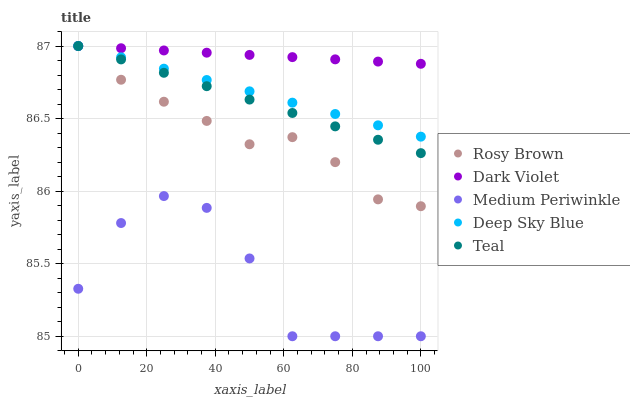Does Medium Periwinkle have the minimum area under the curve?
Answer yes or no. Yes. Does Dark Violet have the maximum area under the curve?
Answer yes or no. Yes. Does Rosy Brown have the minimum area under the curve?
Answer yes or no. No. Does Rosy Brown have the maximum area under the curve?
Answer yes or no. No. Is Dark Violet the smoothest?
Answer yes or no. Yes. Is Medium Periwinkle the roughest?
Answer yes or no. Yes. Is Rosy Brown the smoothest?
Answer yes or no. No. Is Rosy Brown the roughest?
Answer yes or no. No. Does Medium Periwinkle have the lowest value?
Answer yes or no. Yes. Does Rosy Brown have the lowest value?
Answer yes or no. No. Does Dark Violet have the highest value?
Answer yes or no. Yes. Does Medium Periwinkle have the highest value?
Answer yes or no. No. Is Medium Periwinkle less than Teal?
Answer yes or no. Yes. Is Rosy Brown greater than Medium Periwinkle?
Answer yes or no. Yes. Does Teal intersect Dark Violet?
Answer yes or no. Yes. Is Teal less than Dark Violet?
Answer yes or no. No. Is Teal greater than Dark Violet?
Answer yes or no. No. Does Medium Periwinkle intersect Teal?
Answer yes or no. No. 